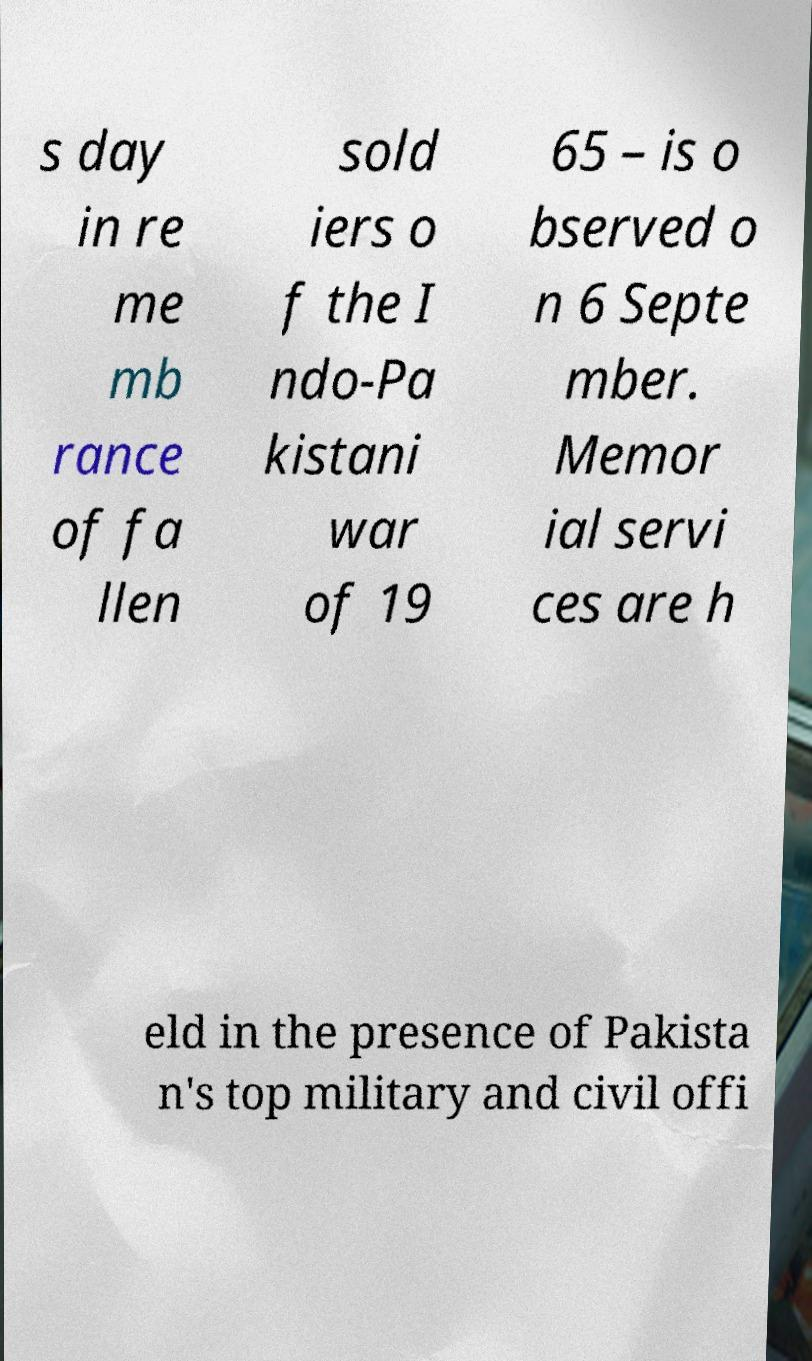Please identify and transcribe the text found in this image. s day in re me mb rance of fa llen sold iers o f the I ndo-Pa kistani war of 19 65 – is o bserved o n 6 Septe mber. Memor ial servi ces are h eld in the presence of Pakista n's top military and civil offi 